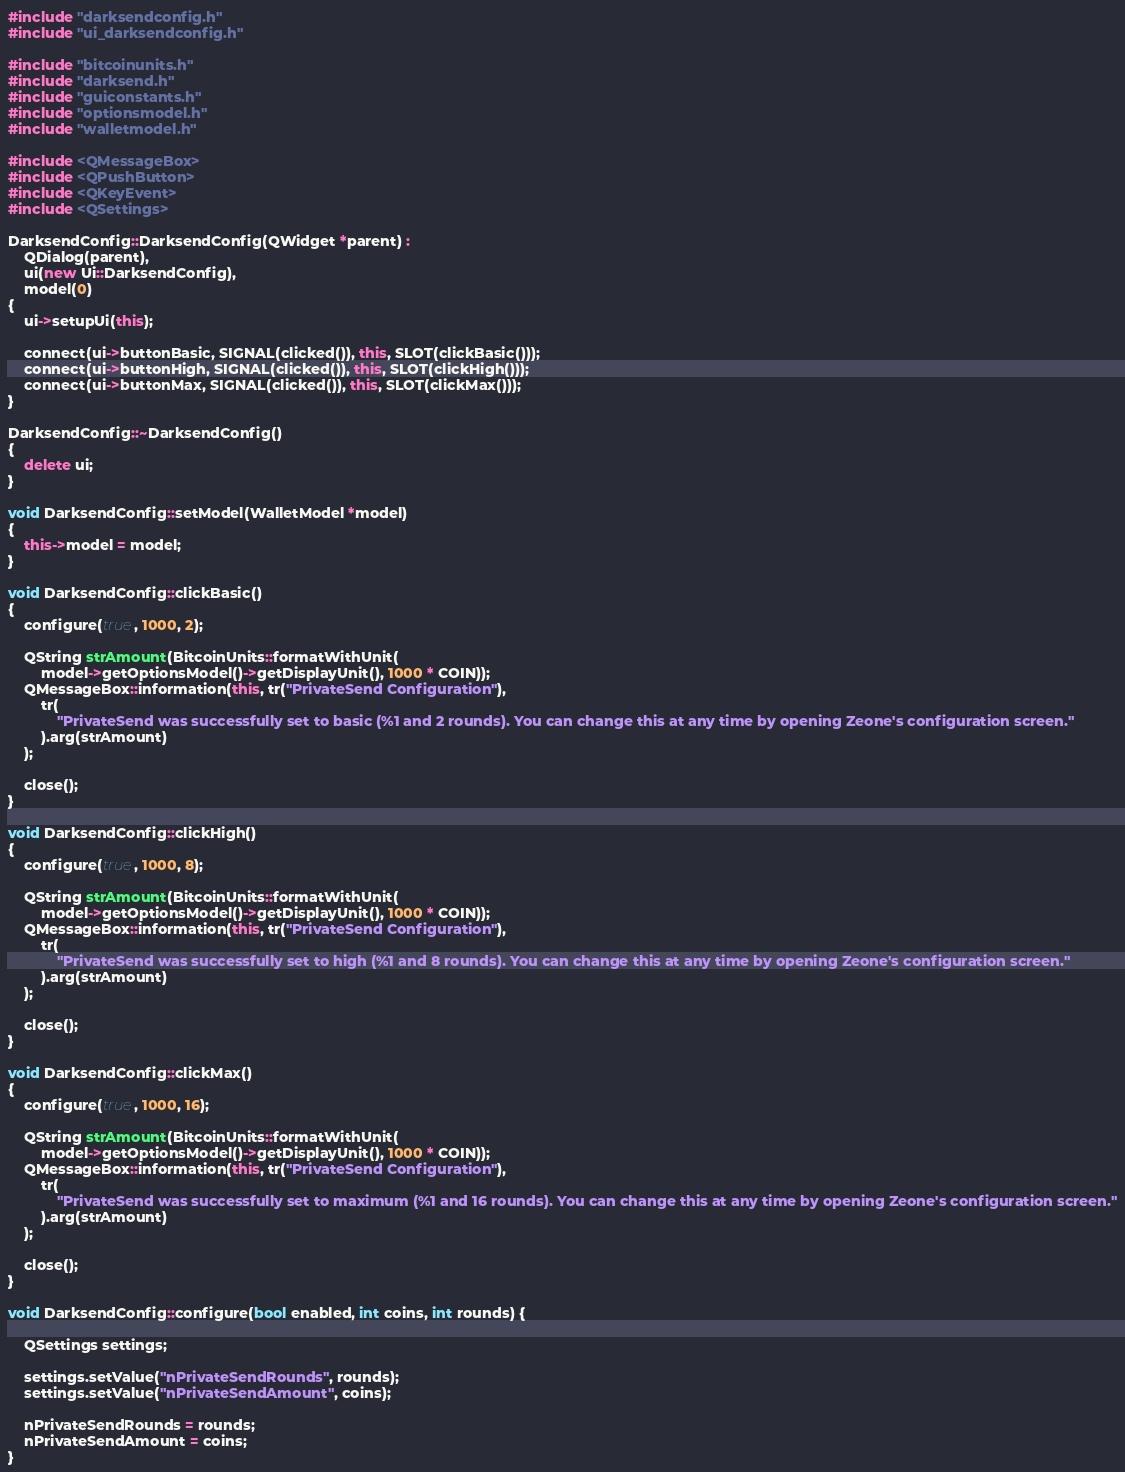<code> <loc_0><loc_0><loc_500><loc_500><_C++_>#include "darksendconfig.h"
#include "ui_darksendconfig.h"

#include "bitcoinunits.h"
#include "darksend.h"
#include "guiconstants.h"
#include "optionsmodel.h"
#include "walletmodel.h"

#include <QMessageBox>
#include <QPushButton>
#include <QKeyEvent>
#include <QSettings>

DarksendConfig::DarksendConfig(QWidget *parent) :
    QDialog(parent),
    ui(new Ui::DarksendConfig),
    model(0)
{
    ui->setupUi(this);

    connect(ui->buttonBasic, SIGNAL(clicked()), this, SLOT(clickBasic()));
    connect(ui->buttonHigh, SIGNAL(clicked()), this, SLOT(clickHigh()));
    connect(ui->buttonMax, SIGNAL(clicked()), this, SLOT(clickMax()));
}

DarksendConfig::~DarksendConfig()
{
    delete ui;
}

void DarksendConfig::setModel(WalletModel *model)
{
    this->model = model;
}

void DarksendConfig::clickBasic()
{
    configure(true, 1000, 2);

    QString strAmount(BitcoinUnits::formatWithUnit(
        model->getOptionsModel()->getDisplayUnit(), 1000 * COIN));
    QMessageBox::information(this, tr("PrivateSend Configuration"),
        tr(
            "PrivateSend was successfully set to basic (%1 and 2 rounds). You can change this at any time by opening Zeone's configuration screen."
        ).arg(strAmount)
    );

    close();
}

void DarksendConfig::clickHigh()
{
    configure(true, 1000, 8);

    QString strAmount(BitcoinUnits::formatWithUnit(
        model->getOptionsModel()->getDisplayUnit(), 1000 * COIN));
    QMessageBox::information(this, tr("PrivateSend Configuration"),
        tr(
            "PrivateSend was successfully set to high (%1 and 8 rounds). You can change this at any time by opening Zeone's configuration screen."
        ).arg(strAmount)
    );

    close();
}

void DarksendConfig::clickMax()
{
    configure(true, 1000, 16);

    QString strAmount(BitcoinUnits::formatWithUnit(
        model->getOptionsModel()->getDisplayUnit(), 1000 * COIN));
    QMessageBox::information(this, tr("PrivateSend Configuration"),
        tr(
            "PrivateSend was successfully set to maximum (%1 and 16 rounds). You can change this at any time by opening Zeone's configuration screen."
        ).arg(strAmount)
    );

    close();
}

void DarksendConfig::configure(bool enabled, int coins, int rounds) {

    QSettings settings;

    settings.setValue("nPrivateSendRounds", rounds);
    settings.setValue("nPrivateSendAmount", coins);

    nPrivateSendRounds = rounds;
    nPrivateSendAmount = coins;
}
</code> 